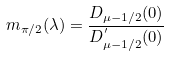<formula> <loc_0><loc_0><loc_500><loc_500>m _ { \pi / 2 } ( \lambda ) = \frac { D _ { \mu - 1 / 2 } ( 0 ) } { D ^ { ^ { \prime } } _ { \mu - 1 / 2 } ( 0 ) }</formula> 